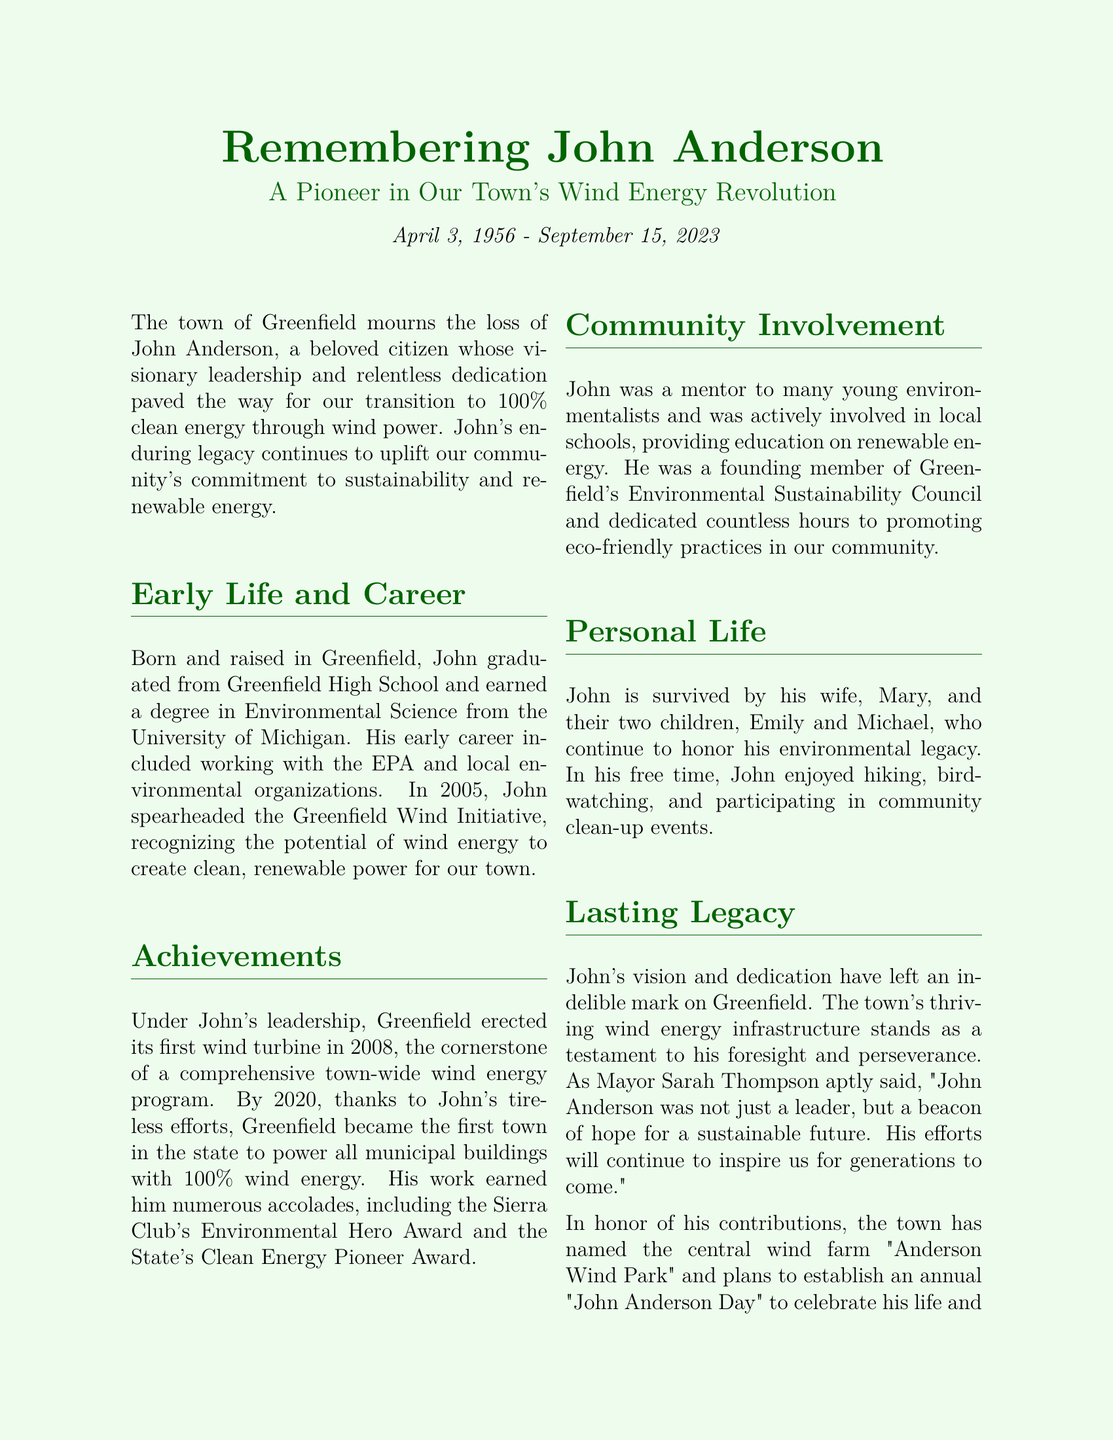what was John Anderson's main contribution? John Anderson's main contribution was his leadership in the transition to 100% clean energy through wind power for the town of Greenfield.
Answer: transition to 100% clean energy when was John Anderson born? John Anderson was born on April 3, 1956, as mentioned in the document.
Answer: April 3, 1956 what award did John Anderson receive from the Sierra Club? The document states that John Anderson received the Sierra Club's Environmental Hero Award.
Answer: Environmental Hero Award what is the name of the wind farm established in his honor? According to the document, the wind farm is named "Anderson Wind Park."
Answer: Anderson Wind Park how many children did John Anderson have? The document states that John Anderson is survived by two children, Emily and Michael.
Answer: two children what year did Greenfield power all municipal buildings with wind energy? The document mentions that by 2020, Greenfield powered all municipal buildings with wind energy.
Answer: 2020 what was one of John Anderson's personal hobbies? The document mentions that John enjoyed hiking as one of his personal hobbies.
Answer: hiking who spoke about John Anderson's legacy in the document? Mayor Sarah Thompson is the individual mentioned who spoke about John Anderson's legacy.
Answer: Mayor Sarah Thompson 